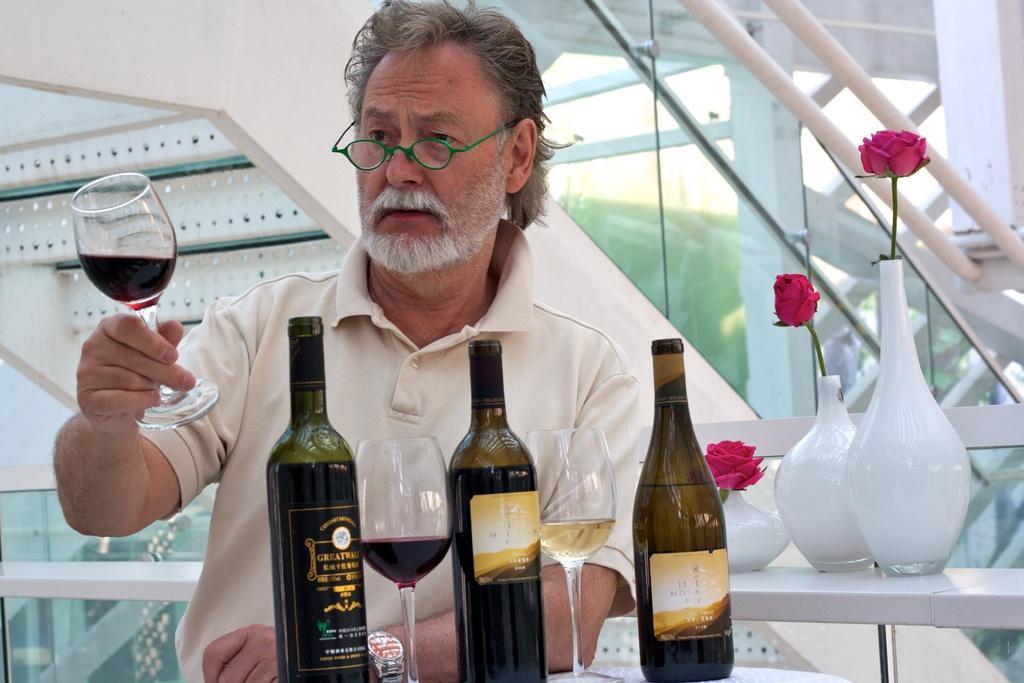Describe this image in one or two sentences. In this picture we can see a man. He wore green colour spectacles and we can see glass of wine in his hand. These are the bottles in front of him and also there is a liquid in both the glasses. This is a table which is in white colour. Here we can see pink color flowers in a white colour vase. 